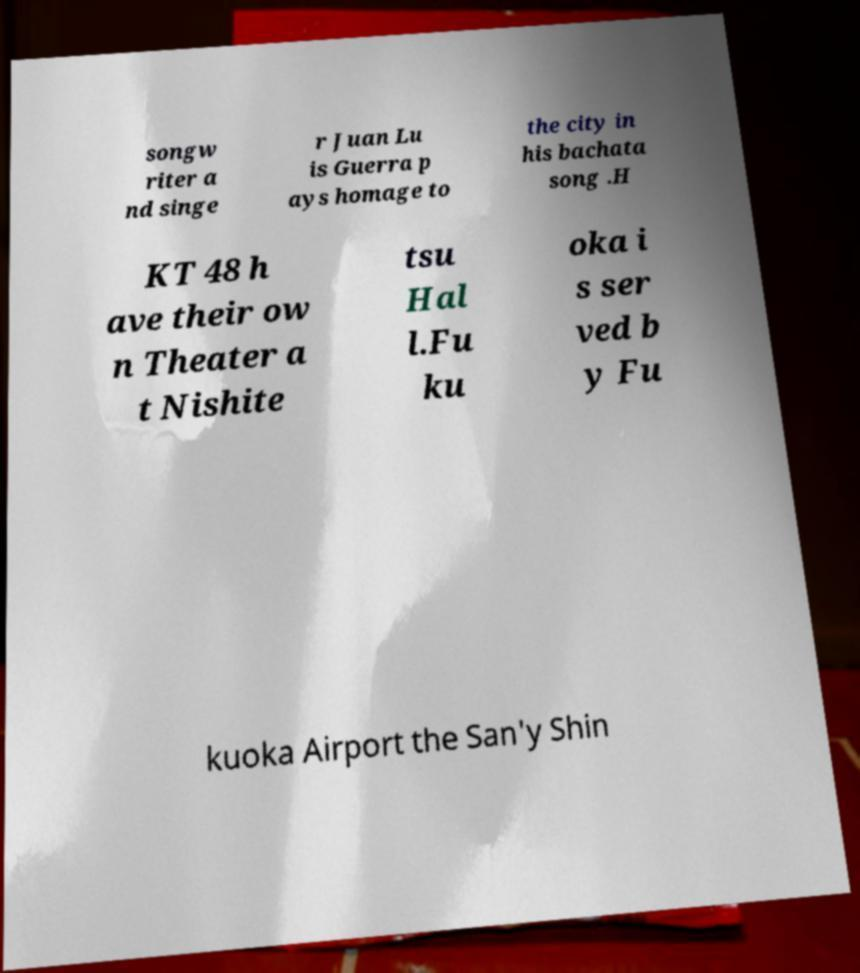Can you read and provide the text displayed in the image?This photo seems to have some interesting text. Can you extract and type it out for me? songw riter a nd singe r Juan Lu is Guerra p ays homage to the city in his bachata song .H KT 48 h ave their ow n Theater a t Nishite tsu Hal l.Fu ku oka i s ser ved b y Fu kuoka Airport the San'y Shin 